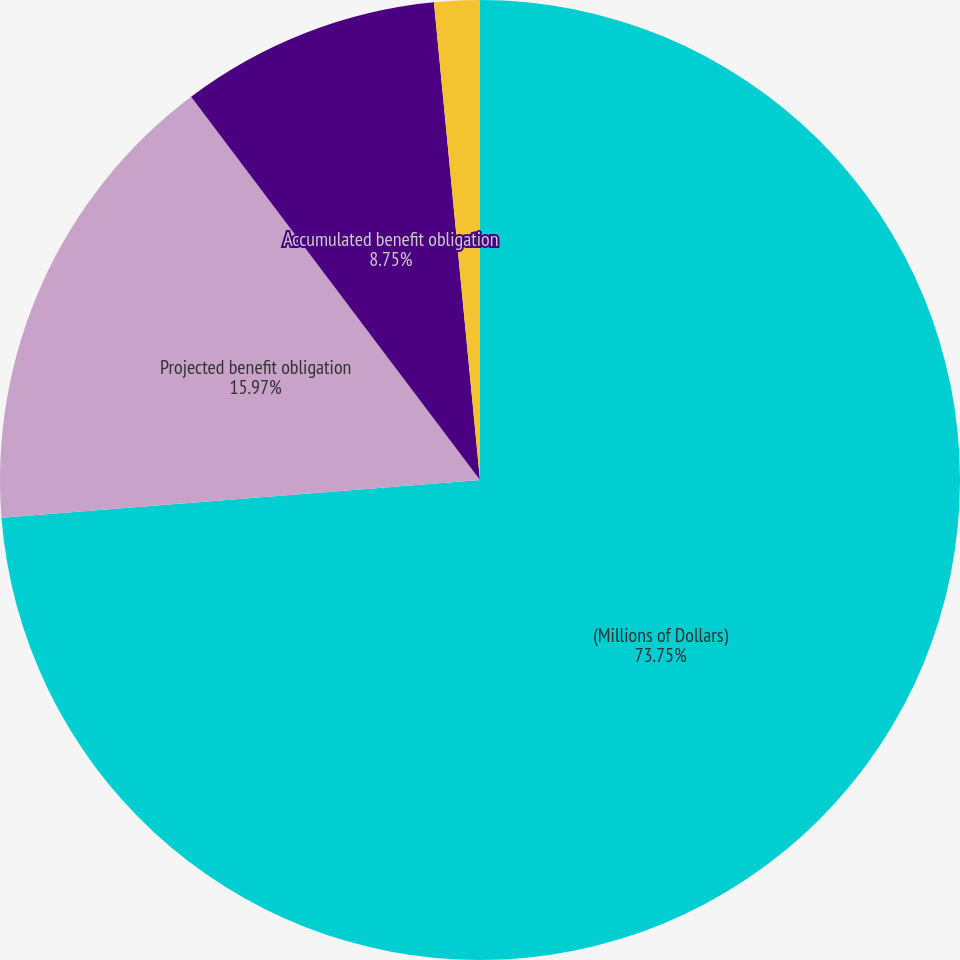<chart> <loc_0><loc_0><loc_500><loc_500><pie_chart><fcel>(Millions of Dollars)<fcel>Projected benefit obligation<fcel>Accumulated benefit obligation<fcel>Fair value of plan assets<nl><fcel>73.75%<fcel>15.97%<fcel>8.75%<fcel>1.53%<nl></chart> 